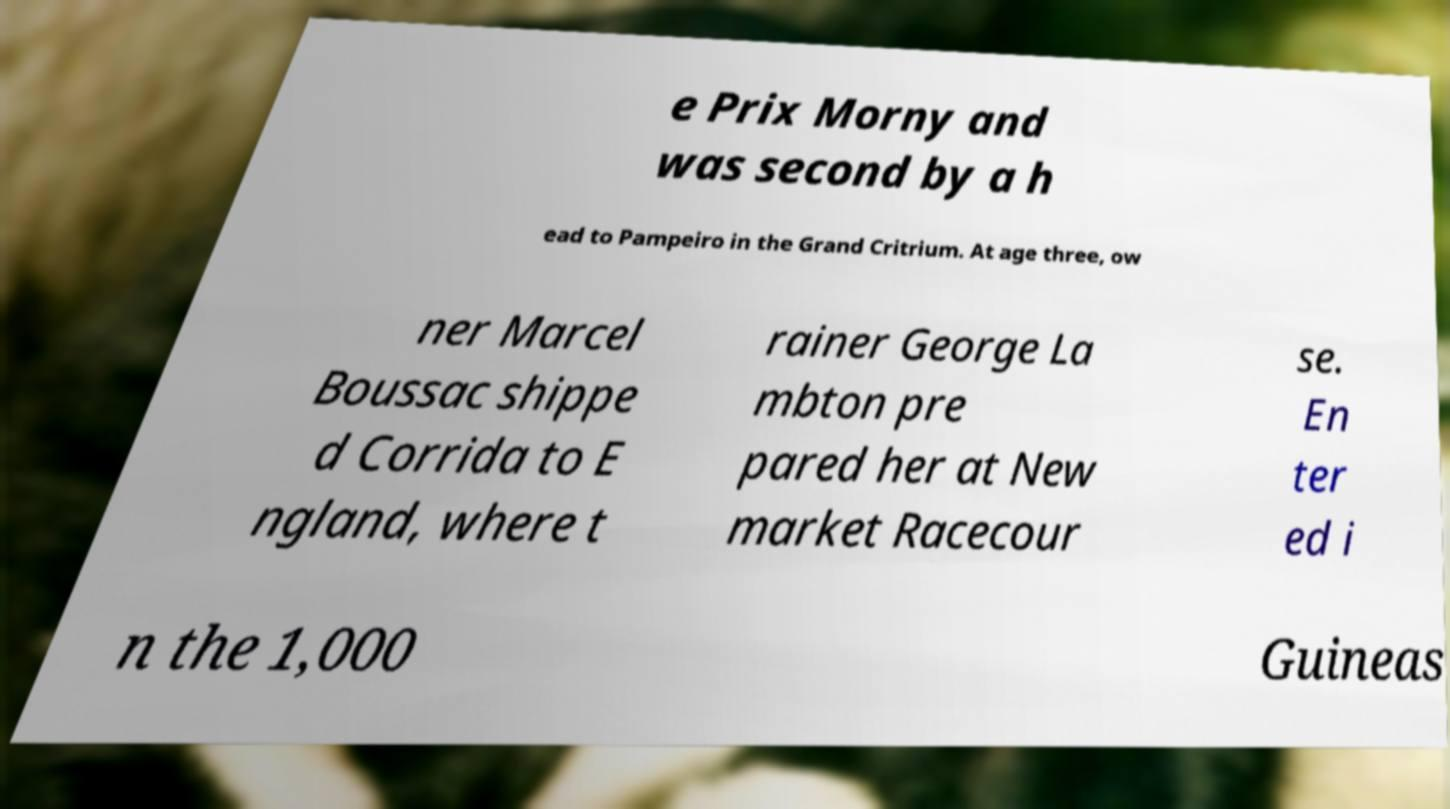Please read and relay the text visible in this image. What does it say? e Prix Morny and was second by a h ead to Pampeiro in the Grand Critrium. At age three, ow ner Marcel Boussac shippe d Corrida to E ngland, where t rainer George La mbton pre pared her at New market Racecour se. En ter ed i n the 1,000 Guineas 